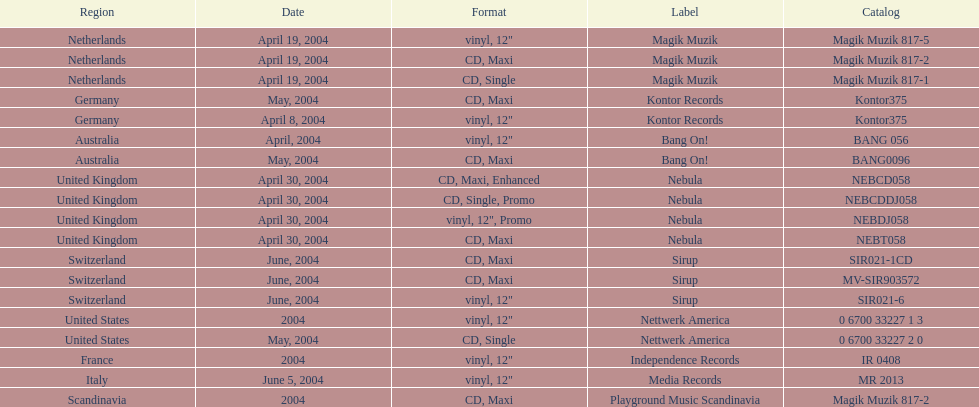What label was italy on? Media Records. 